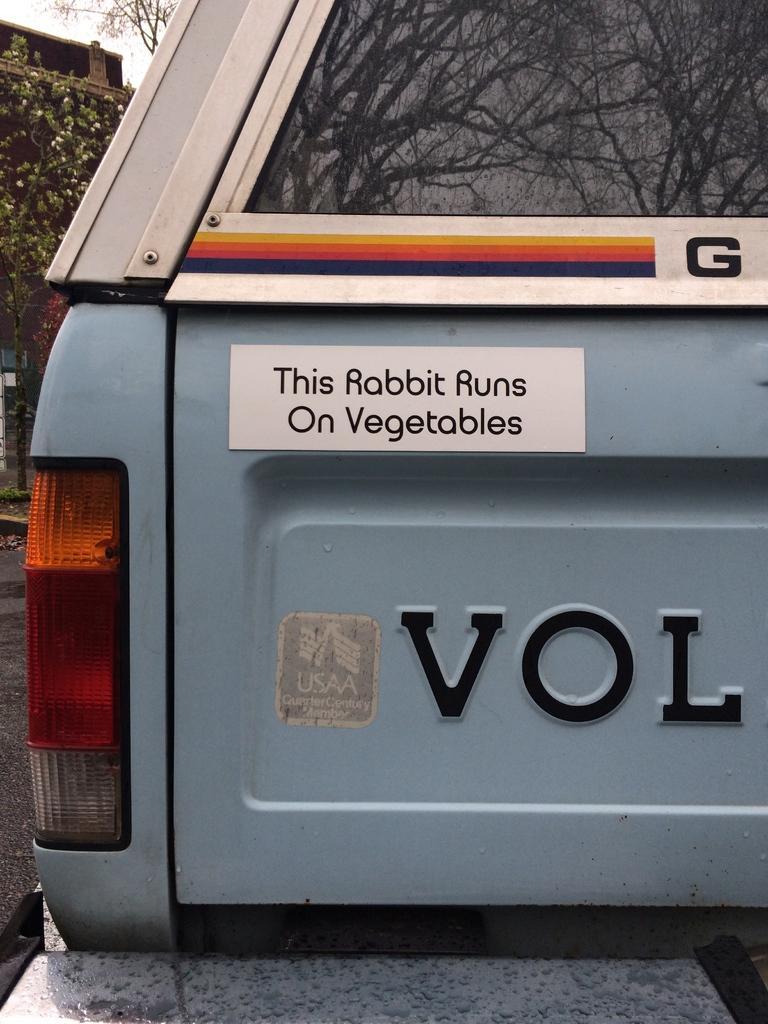Please provide a concise description of this image. In this image we can see back side of the vehicle with tail light, glass window. On the window there is reflection of trees. Also there is a board with something written. On the left side there are trees. 